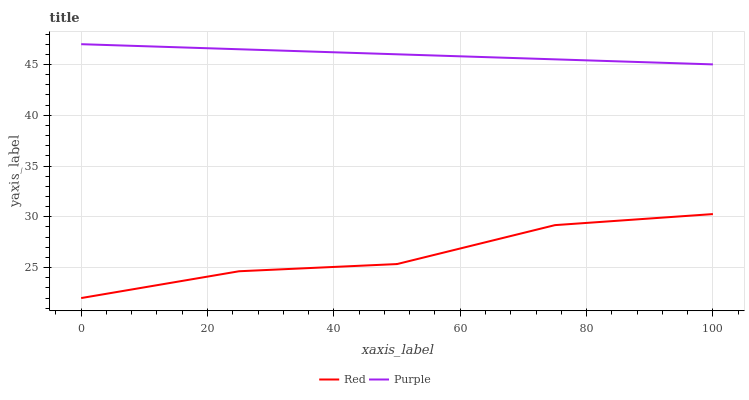Does Red have the minimum area under the curve?
Answer yes or no. Yes. Does Purple have the maximum area under the curve?
Answer yes or no. Yes. Does Red have the maximum area under the curve?
Answer yes or no. No. Is Purple the smoothest?
Answer yes or no. Yes. Is Red the roughest?
Answer yes or no. Yes. Is Red the smoothest?
Answer yes or no. No. Does Red have the lowest value?
Answer yes or no. Yes. Does Purple have the highest value?
Answer yes or no. Yes. Does Red have the highest value?
Answer yes or no. No. Is Red less than Purple?
Answer yes or no. Yes. Is Purple greater than Red?
Answer yes or no. Yes. Does Red intersect Purple?
Answer yes or no. No. 